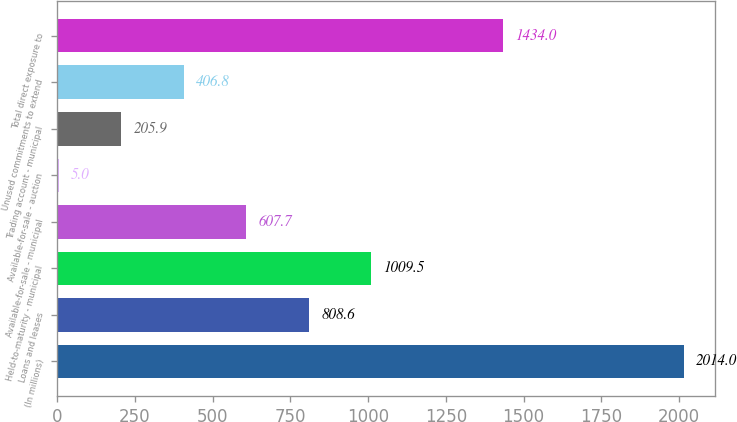Convert chart. <chart><loc_0><loc_0><loc_500><loc_500><bar_chart><fcel>(In millions)<fcel>Loans and leases<fcel>Held-to-maturity - municipal<fcel>Available-for-sale - municipal<fcel>Available-for-sale - auction<fcel>Trading account - municipal<fcel>Unused commitments to extend<fcel>Total direct exposure to<nl><fcel>2014<fcel>808.6<fcel>1009.5<fcel>607.7<fcel>5<fcel>205.9<fcel>406.8<fcel>1434<nl></chart> 